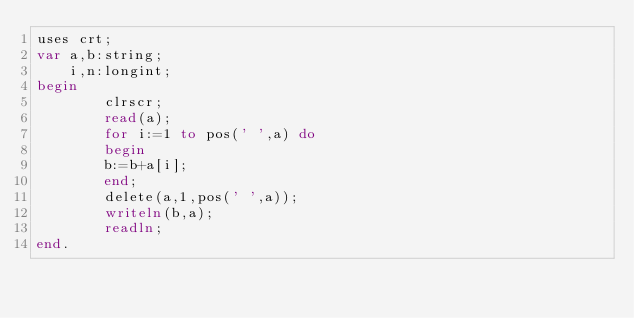<code> <loc_0><loc_0><loc_500><loc_500><_Pascal_>uses crt;
var a,b:string;
    i,n:longint;
begin
        clrscr;
        read(a);
        for i:=1 to pos(' ',a) do
        begin
        b:=b+a[i];
        end;
        delete(a,1,pos(' ',a));
        writeln(b,a);
        readln;
end.


</code> 